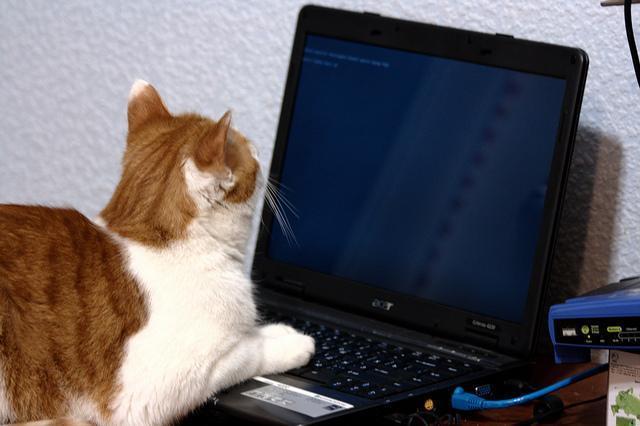How many cats are there?
Give a very brief answer. 1. 